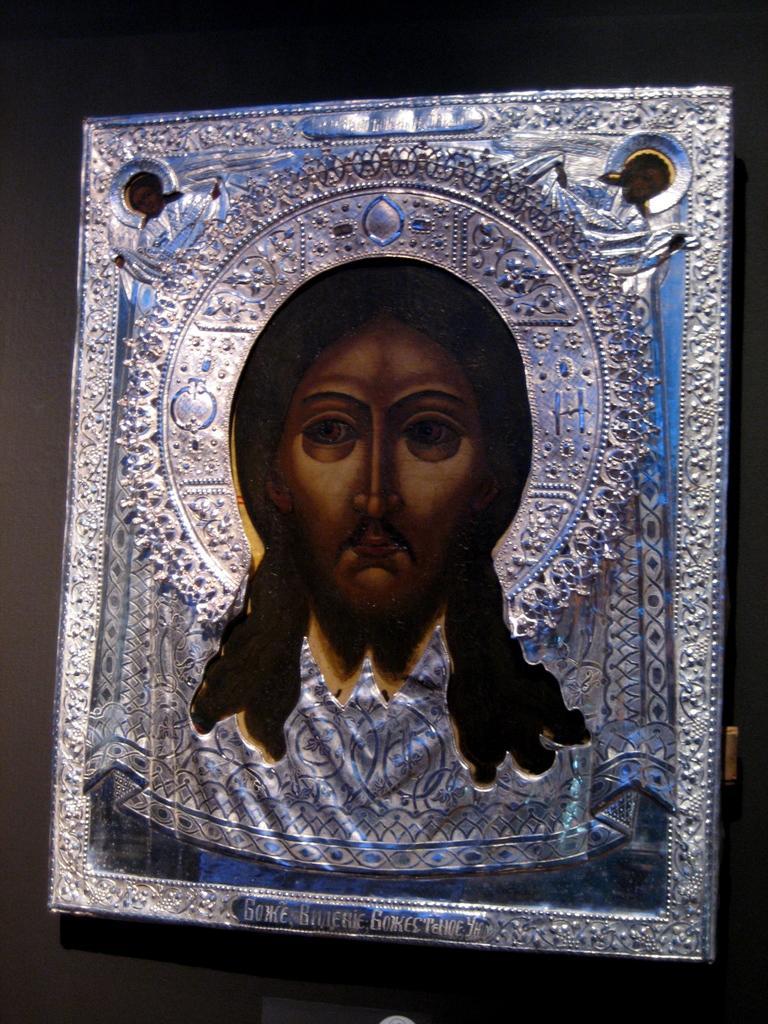Can you describe this image briefly? This is a frame and we can see a picture of a person on the frame and it is on a platform. 